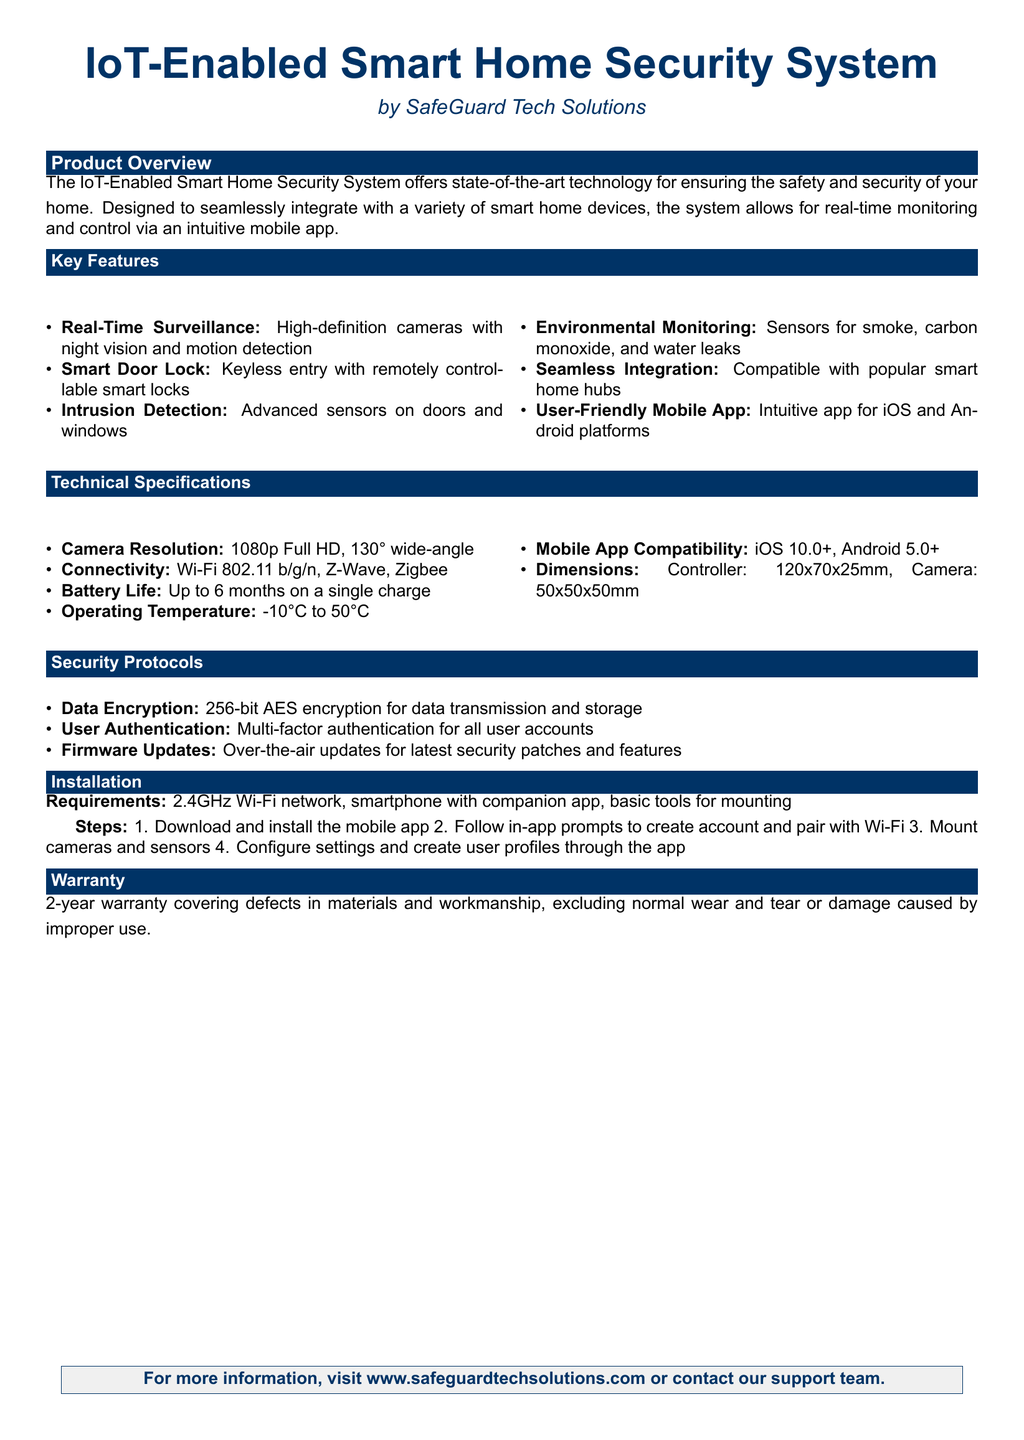What is the resolution of the cameras? The document specifies that the camera resolution is 1080p Full HD.
Answer: 1080p Full HD What type of authentication is used for user accounts? The specification states that multi-factor authentication is employed for user accounts.
Answer: Multi-factor authentication What is the operating temperature range for the system? The document details that the operating temperature ranges from -10°C to 50°C.
Answer: -10°C to 50°C How long is the warranty period for the security system? The warranty period mentioned in the document is 2 years.
Answer: 2 years What is required for installation regarding the Wi-Fi network? The installation requirements specify that a 2.4GHz Wi-Fi network is necessary.
Answer: 2.4GHz Wi-Fi network Which mobile platforms is the app compatible with? The document states the mobile app is compatible with iOS 10.0+ and Android 5.0+.
Answer: iOS 10.0+, Android 5.0+ Name one environmental sensor included in the system. The system includes sensors for detecting smoke, among others.
Answer: Smoke How is data encryption handled in this system? The document mentions that 256-bit AES encryption is used for data transmission and storage.
Answer: 256-bit AES encryption What type of app is provided for controlling the system? The document describes the app as an intuitive mobile app.
Answer: Intuitive mobile app 